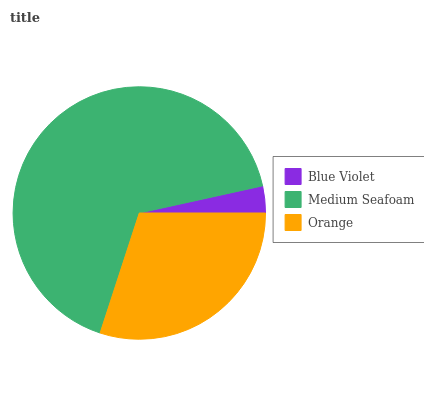Is Blue Violet the minimum?
Answer yes or no. Yes. Is Medium Seafoam the maximum?
Answer yes or no. Yes. Is Orange the minimum?
Answer yes or no. No. Is Orange the maximum?
Answer yes or no. No. Is Medium Seafoam greater than Orange?
Answer yes or no. Yes. Is Orange less than Medium Seafoam?
Answer yes or no. Yes. Is Orange greater than Medium Seafoam?
Answer yes or no. No. Is Medium Seafoam less than Orange?
Answer yes or no. No. Is Orange the high median?
Answer yes or no. Yes. Is Orange the low median?
Answer yes or no. Yes. Is Medium Seafoam the high median?
Answer yes or no. No. Is Medium Seafoam the low median?
Answer yes or no. No. 